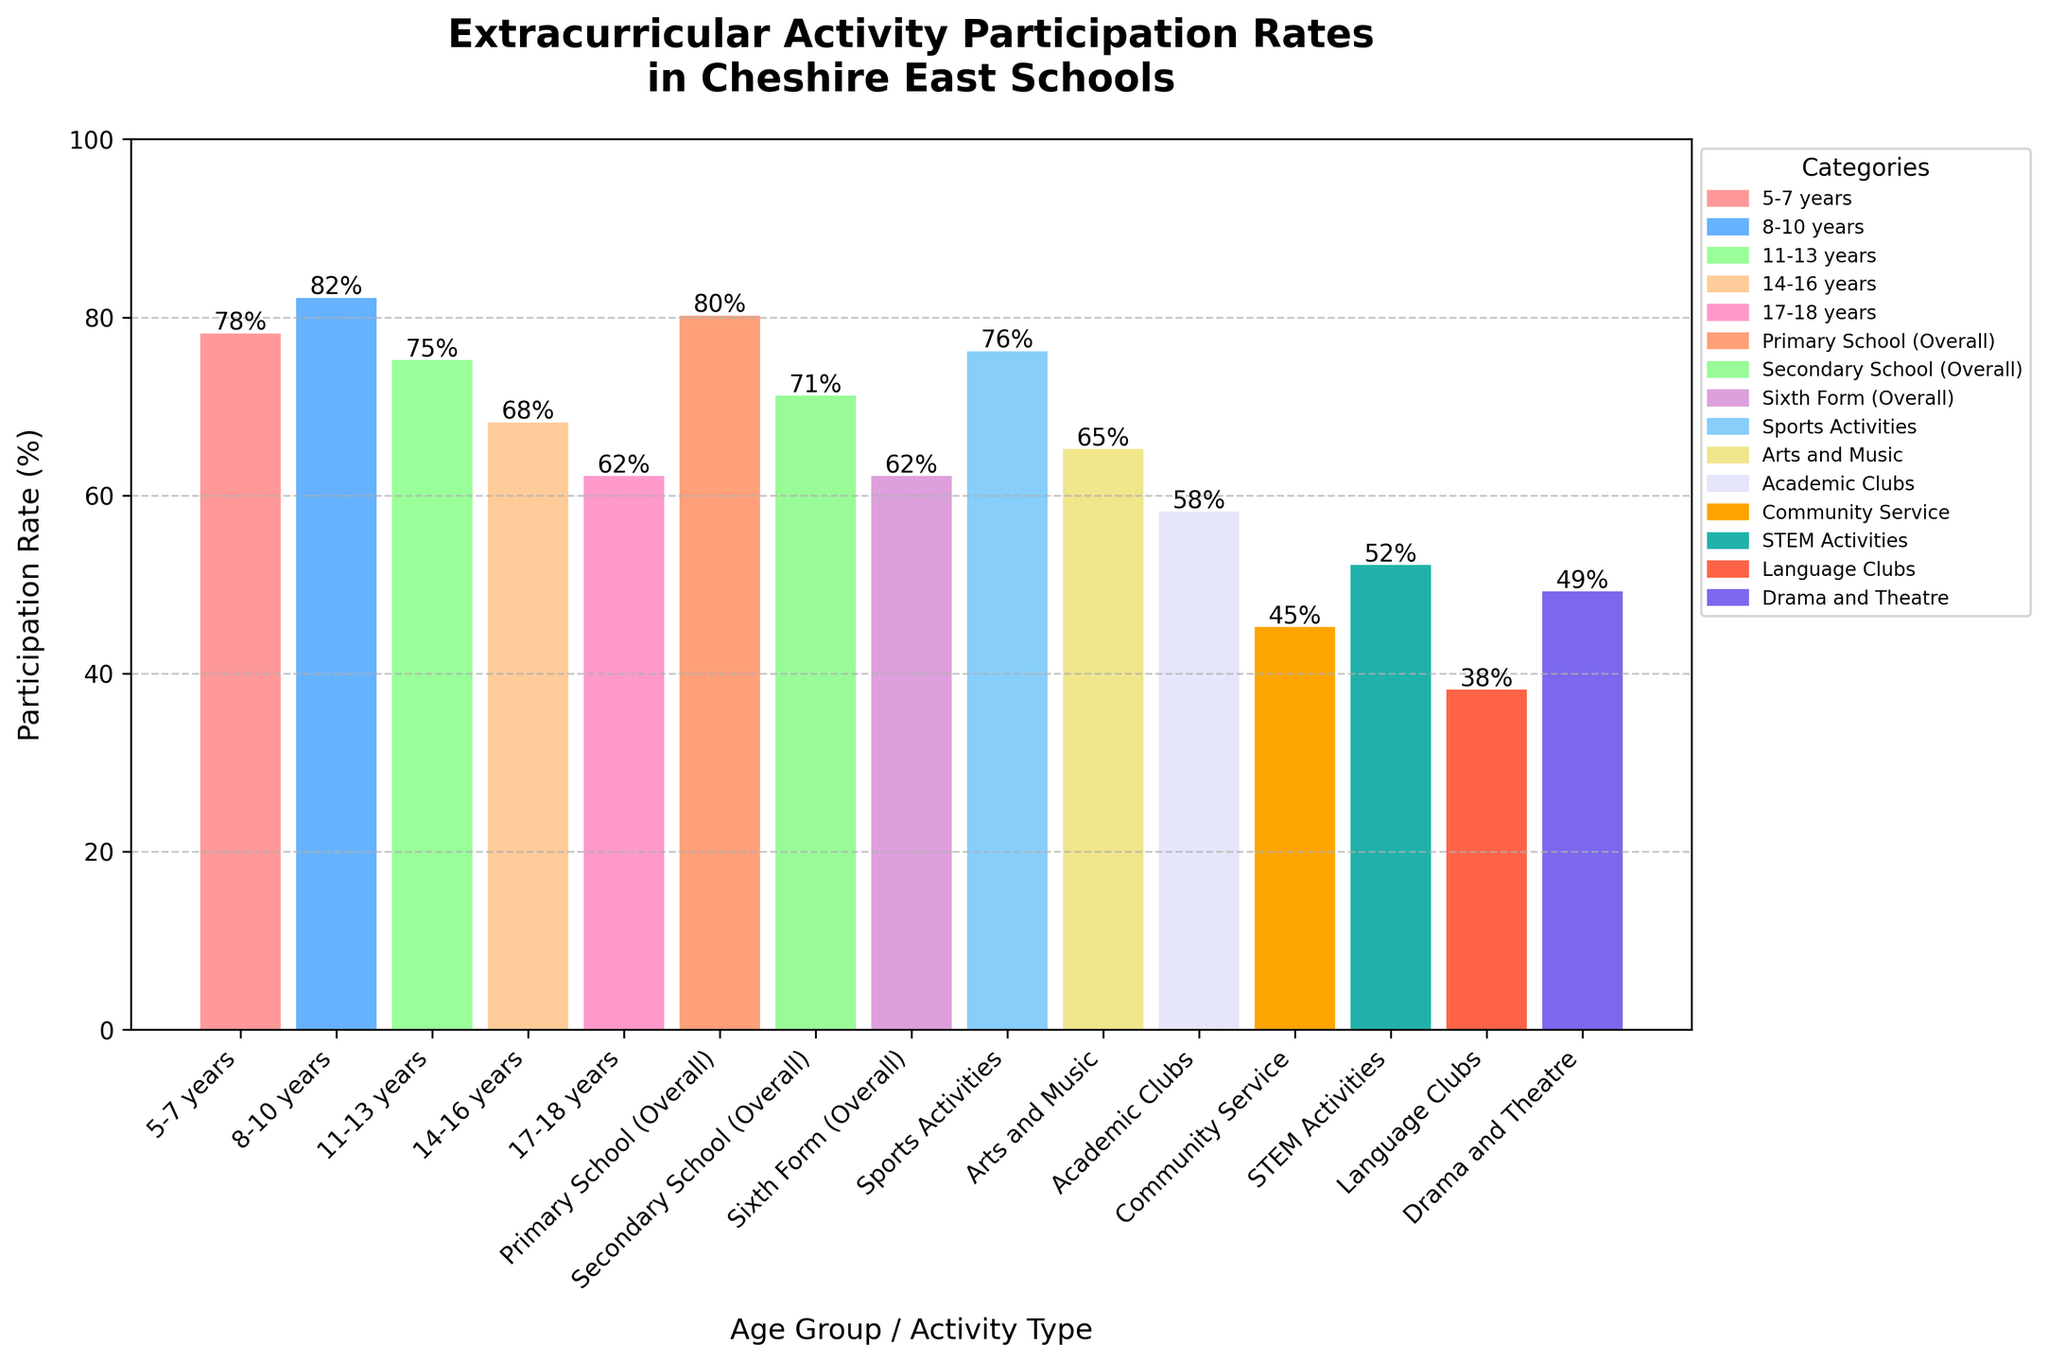What age group has the highest participation rate? By observing the height of the bars, the age group with the highest participation rate can be found. The 8-10 years group has the tallest bar, indicating the highest participation rate.
Answer: 8-10 years What is the difference in participation rates between the Primary School (Overall) and the Secondary School (Overall)? Locate the bars for both Primary School (Overall) and Secondary School (Overall) and subtract the participation rate of Secondary from Primary. Primary School (Overall) is 80%, and Secondary School (Overall) is 71%, so the difference is 80% - 71%.
Answer: 9% What is the average participation rate across all activity types listed (Sports Activities, Arts and Music, Academic Clubs, Community Service, STEM Activities, Language Clubs, Drama and Theatre)? Sum up the participation rates of the listed activities and divide by the number of activities (7). (76 + 65 + 58 + 45 + 52 + 38 + 49) / 7 = 383 / 7.
Answer: 54.71% Which age group has a lower participation rate than Arts and Music activities and by how much? Compare the height of the bars of different age groups with the bar for Arts and Music activities (65%). The 11-13 years (75%), 14-16 years (68%), and 17-18 years (62%) age groups need to be compared to see which one is lower and by how much.
Answer: 17-18 years, 3% What color is used to represent the participation rate of the STEM Activities? Identify the bar corresponding to STEM Activities by its label and observe its color.
Answer: Green What is the median participation rate among all the age groups? List the participation rates of all age groups (78, 82, 75, 68, 62, 80, 71, 62) in ascending order (62, 62, 68, 71, 75, 78, 80, 82) and find the middle value(s). Since there are 8 values, the median is the average of the 4th and 5th values ((71+75)/2).
Answer: 73% Which category has the lowest participation rate, and by what percent is it lower than Academic Clubs? Identify the category with the shortest bar and note its participation rate. Language Clubs have the lowest rate (38%). Compare this with Academic Clubs (58%) and calculate the difference (58 - 38%).
Answer: Language Clubs, 20% How many age groups have a participation rate below 70%? Count the bars representing different age groups that have a height corresponding to a participation rate below 70%. These are the 14-16 years (68%) and 17-18 years (62%) age groups.
Answer: 2 What is the percentage increase in participation from STEM Activities to Sports Activities? Find the participation rates of both STEM Activities (52%) and Sports Activities (76%), then calculate the percentage increase ((76 - 52) / 52) * 100.
Answer: 46.15% 